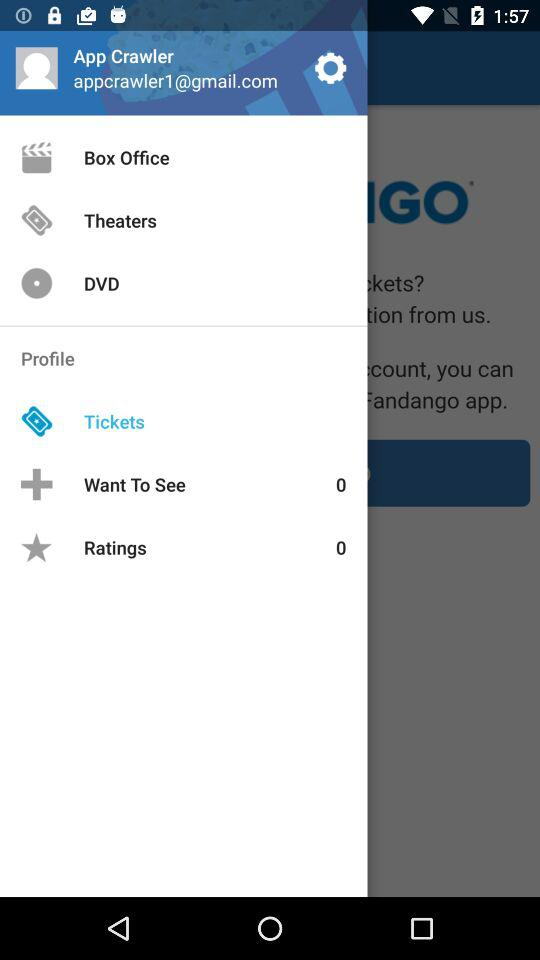What's the user profile name? The user profile name is App Crawler. 